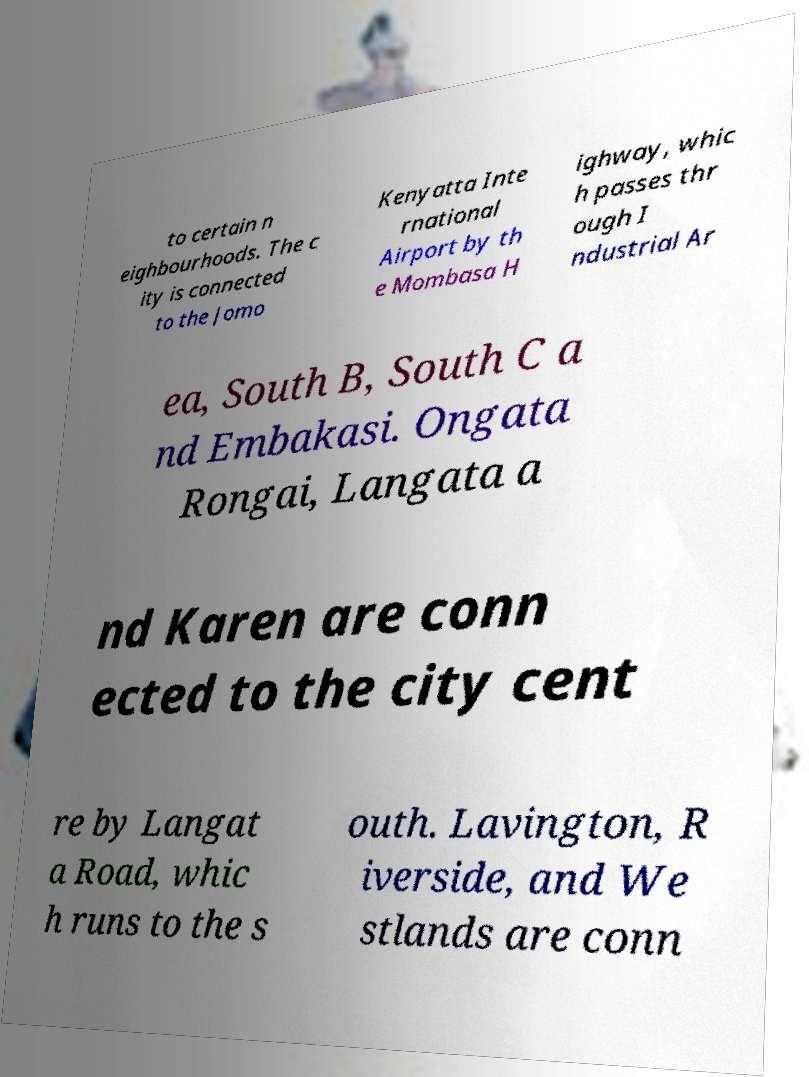Can you read and provide the text displayed in the image?This photo seems to have some interesting text. Can you extract and type it out for me? to certain n eighbourhoods. The c ity is connected to the Jomo Kenyatta Inte rnational Airport by th e Mombasa H ighway, whic h passes thr ough I ndustrial Ar ea, South B, South C a nd Embakasi. Ongata Rongai, Langata a nd Karen are conn ected to the city cent re by Langat a Road, whic h runs to the s outh. Lavington, R iverside, and We stlands are conn 